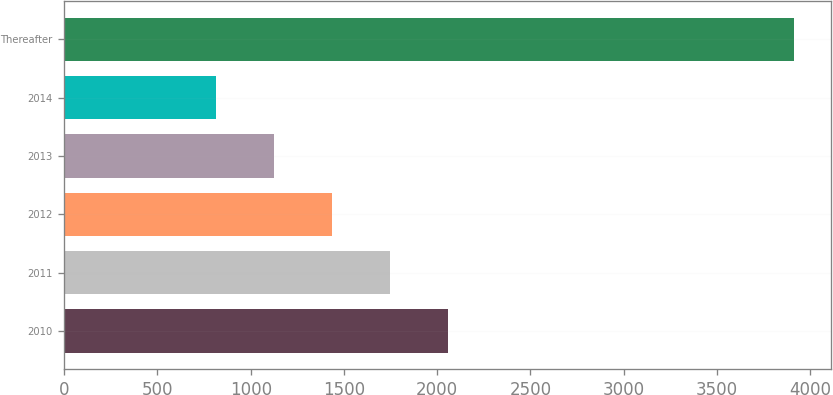Convert chart to OTSL. <chart><loc_0><loc_0><loc_500><loc_500><bar_chart><fcel>2010<fcel>2011<fcel>2012<fcel>2013<fcel>2014<fcel>Thereafter<nl><fcel>2056<fcel>1746<fcel>1436<fcel>1126<fcel>816<fcel>3916<nl></chart> 